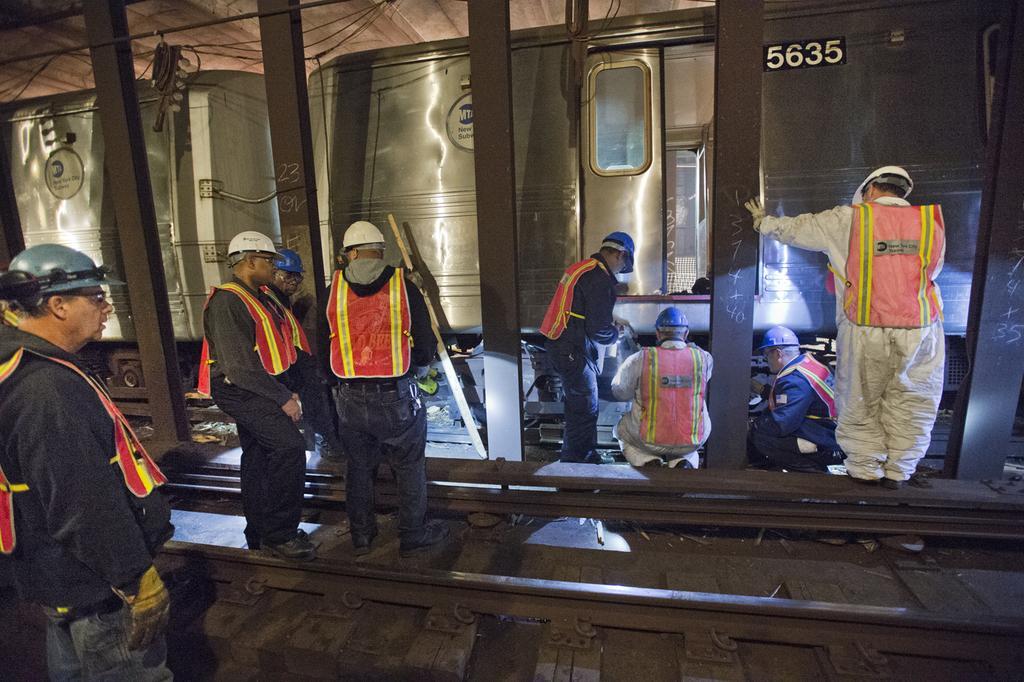Describe this image in one or two sentences. In this picture I can see two persons who are sitting near to the train's wheel, beside him I can see a man who is wearing helmet, jacket, shirt and trouser. He is standing near to the door. On the left there are three persons who are standing near to the railway tracks. In the bottom left there is a man who is wearing helmet, jacket, shirt and jeans. On the right there is another man who is standing on this track. Beside him I can see the pillars. At the top I can see some cables. 